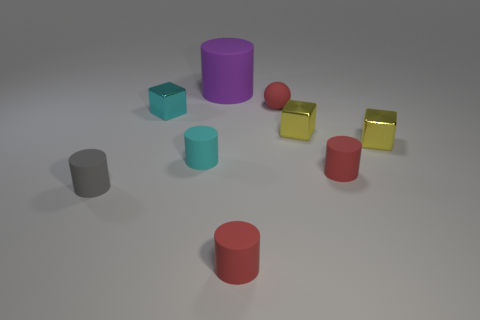Subtract all gray cylinders. How many cylinders are left? 4 Subtract all red rubber cylinders. How many cylinders are left? 3 Subtract all blue cylinders. Subtract all cyan balls. How many cylinders are left? 5 Add 1 small cyan cylinders. How many objects exist? 10 Subtract all cylinders. How many objects are left? 4 Add 8 blue blocks. How many blue blocks exist? 8 Subtract 0 purple spheres. How many objects are left? 9 Subtract all small cyan matte objects. Subtract all purple objects. How many objects are left? 7 Add 2 tiny yellow cubes. How many tiny yellow cubes are left? 4 